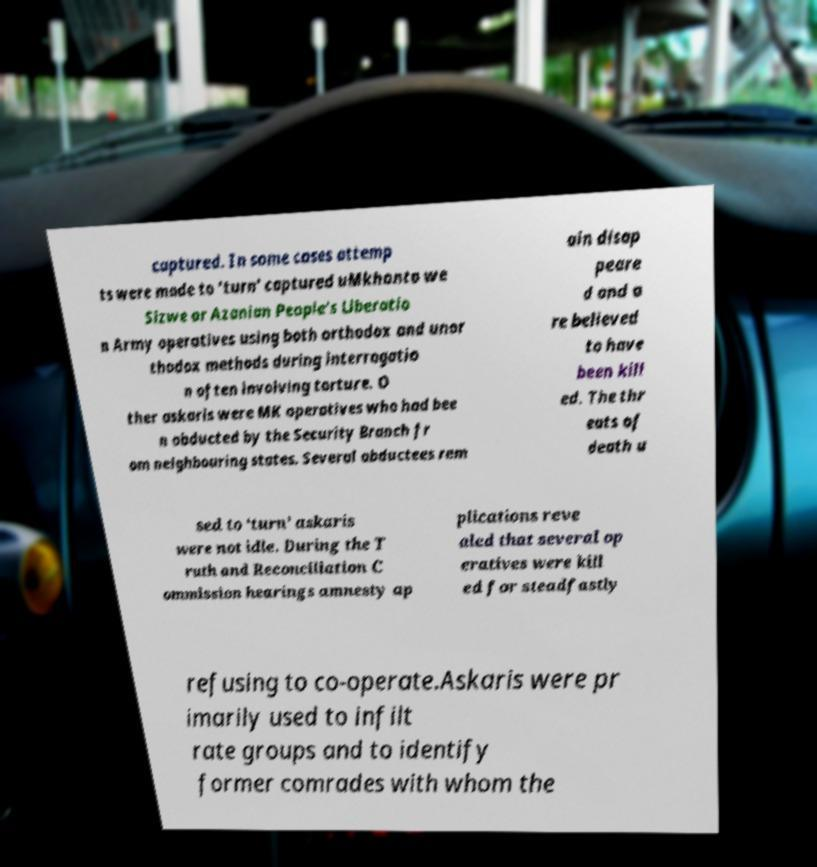Could you assist in decoding the text presented in this image and type it out clearly? captured. In some cases attemp ts were made to ‘turn’ captured uMkhonto we Sizwe or Azanian People's Liberatio n Army operatives using both orthodox and unor thodox methods during interrogatio n often involving torture. O ther askaris were MK operatives who had bee n abducted by the Security Branch fr om neighbouring states. Several abductees rem ain disap peare d and a re believed to have been kill ed. The thr eats of death u sed to ‘turn’ askaris were not idle. During the T ruth and Reconciliation C ommission hearings amnesty ap plications reve aled that several op eratives were kill ed for steadfastly refusing to co-operate.Askaris were pr imarily used to infilt rate groups and to identify former comrades with whom the 